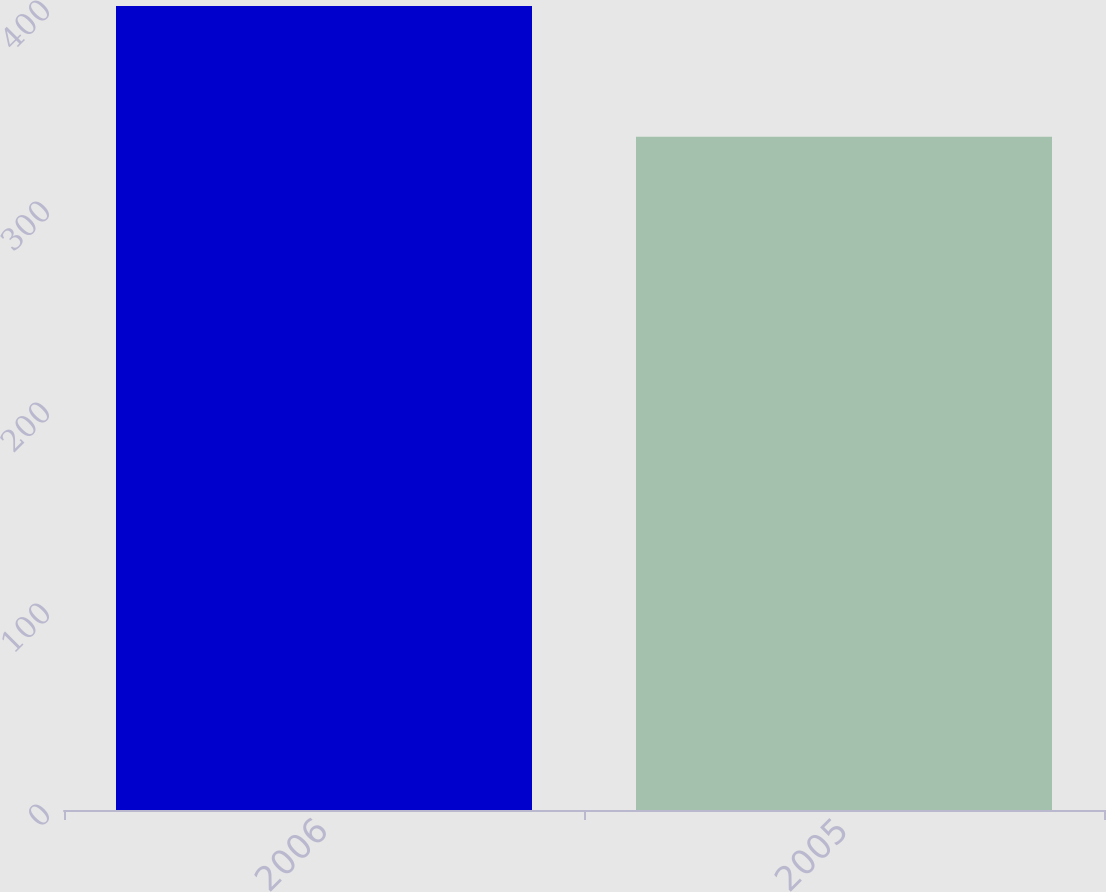<chart> <loc_0><loc_0><loc_500><loc_500><bar_chart><fcel>2006<fcel>2005<nl><fcel>400<fcel>335<nl></chart> 